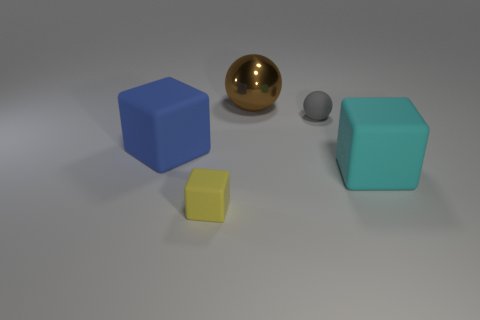There is a large thing that is in front of the large rubber cube to the left of the tiny gray thing; what color is it?
Ensure brevity in your answer.  Cyan. There is a object in front of the big cube that is right of the yellow thing; how big is it?
Provide a short and direct response. Small. What number of other objects are the same size as the gray rubber thing?
Your answer should be compact. 1. What is the color of the rubber thing left of the matte thing in front of the large matte object on the right side of the tiny gray thing?
Ensure brevity in your answer.  Blue. How many other objects are there of the same shape as the big blue object?
Your answer should be very brief. 2. There is a small thing that is in front of the cyan matte cube; what is its shape?
Make the answer very short. Cube. There is a big rubber block right of the blue thing; are there any cubes that are to the left of it?
Your answer should be very brief. Yes. What is the color of the large object that is both in front of the gray rubber sphere and on the left side of the big cyan cube?
Offer a terse response. Blue. Are there any brown shiny objects that are to the left of the yellow rubber thing in front of the matte cube behind the large cyan rubber block?
Offer a terse response. No. There is a yellow thing that is the same shape as the big blue thing; what is its size?
Offer a terse response. Small. 